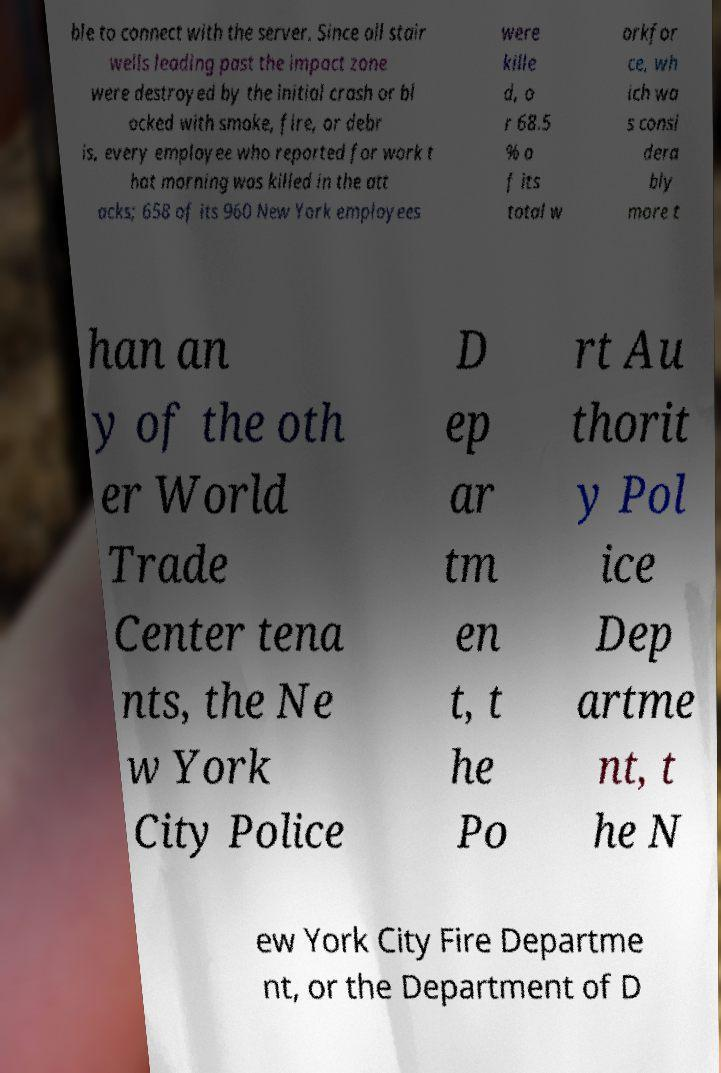There's text embedded in this image that I need extracted. Can you transcribe it verbatim? ble to connect with the server. Since all stair wells leading past the impact zone were destroyed by the initial crash or bl ocked with smoke, fire, or debr is, every employee who reported for work t hat morning was killed in the att acks; 658 of its 960 New York employees were kille d, o r 68.5 % o f its total w orkfor ce, wh ich wa s consi dera bly more t han an y of the oth er World Trade Center tena nts, the Ne w York City Police D ep ar tm en t, t he Po rt Au thorit y Pol ice Dep artme nt, t he N ew York City Fire Departme nt, or the Department of D 